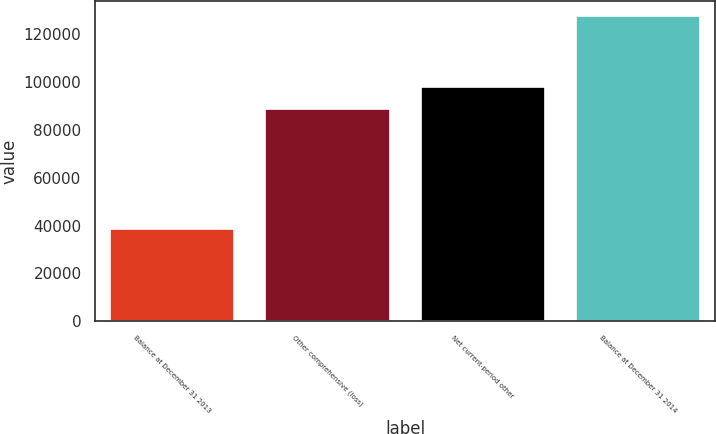Convert chart to OTSL. <chart><loc_0><loc_0><loc_500><loc_500><bar_chart><fcel>Balance at December 31 2013<fcel>Other comprehensive (loss)<fcel>Net current-period other<fcel>Balance at December 31 2014<nl><fcel>38767<fcel>88944<fcel>97838.4<fcel>127711<nl></chart> 